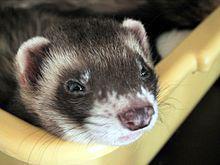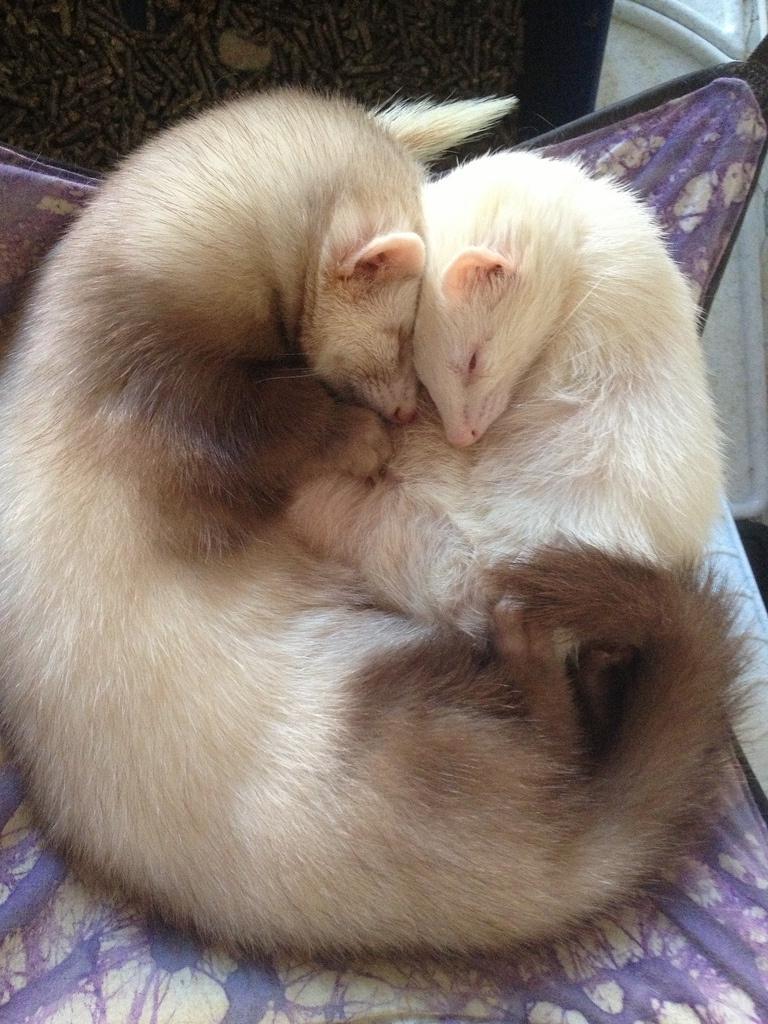The first image is the image on the left, the second image is the image on the right. Given the left and right images, does the statement "The left image contains two ferrets." hold true? Answer yes or no. No. The first image is the image on the left, the second image is the image on the right. Considering the images on both sides, is "At least one ferret has its front paws draped over an edge, and multiple ferrets are peering forward." valid? Answer yes or no. No. 